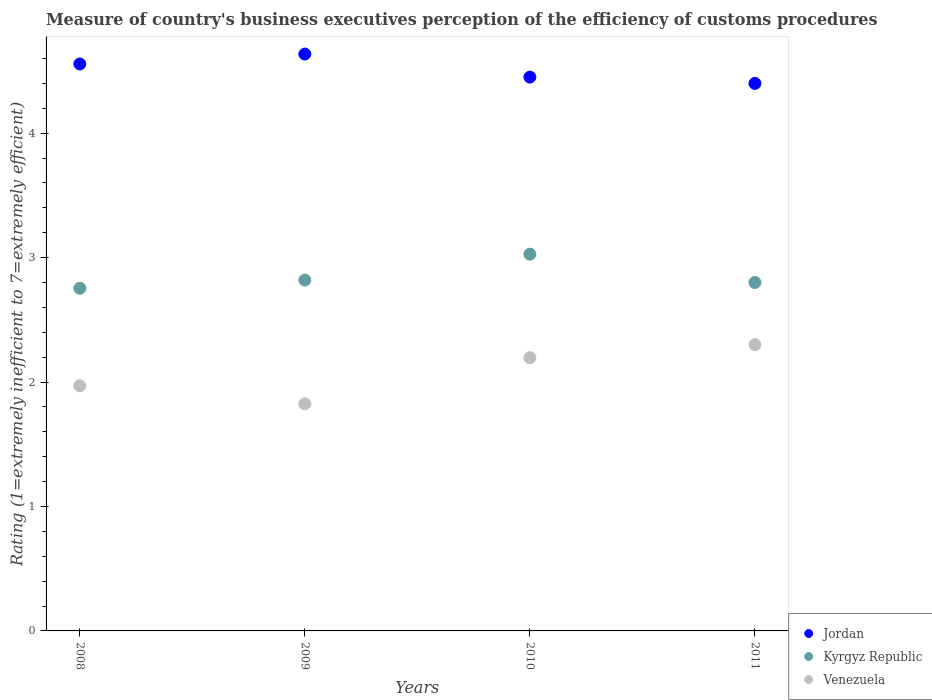What is the rating of the efficiency of customs procedure in Jordan in 2010?
Keep it short and to the point. 4.45. Across all years, what is the minimum rating of the efficiency of customs procedure in Venezuela?
Make the answer very short. 1.83. In which year was the rating of the efficiency of customs procedure in Kyrgyz Republic minimum?
Give a very brief answer. 2008. What is the total rating of the efficiency of customs procedure in Kyrgyz Republic in the graph?
Your response must be concise. 11.4. What is the difference between the rating of the efficiency of customs procedure in Jordan in 2010 and that in 2011?
Offer a terse response. 0.05. What is the difference between the rating of the efficiency of customs procedure in Jordan in 2011 and the rating of the efficiency of customs procedure in Kyrgyz Republic in 2008?
Your answer should be compact. 1.65. What is the average rating of the efficiency of customs procedure in Jordan per year?
Provide a short and direct response. 4.51. In the year 2009, what is the difference between the rating of the efficiency of customs procedure in Venezuela and rating of the efficiency of customs procedure in Jordan?
Keep it short and to the point. -2.81. In how many years, is the rating of the efficiency of customs procedure in Kyrgyz Republic greater than 4.4?
Keep it short and to the point. 0. What is the ratio of the rating of the efficiency of customs procedure in Kyrgyz Republic in 2008 to that in 2011?
Offer a very short reply. 0.98. Is the rating of the efficiency of customs procedure in Venezuela in 2008 less than that in 2009?
Ensure brevity in your answer.  No. What is the difference between the highest and the second highest rating of the efficiency of customs procedure in Venezuela?
Give a very brief answer. 0.1. What is the difference between the highest and the lowest rating of the efficiency of customs procedure in Kyrgyz Republic?
Provide a succinct answer. 0.27. Is the sum of the rating of the efficiency of customs procedure in Kyrgyz Republic in 2008 and 2009 greater than the maximum rating of the efficiency of customs procedure in Venezuela across all years?
Offer a very short reply. Yes. Is the rating of the efficiency of customs procedure in Venezuela strictly greater than the rating of the efficiency of customs procedure in Kyrgyz Republic over the years?
Give a very brief answer. No. How many dotlines are there?
Offer a terse response. 3. What is the difference between two consecutive major ticks on the Y-axis?
Ensure brevity in your answer.  1. Where does the legend appear in the graph?
Give a very brief answer. Bottom right. How many legend labels are there?
Ensure brevity in your answer.  3. How are the legend labels stacked?
Your answer should be compact. Vertical. What is the title of the graph?
Your answer should be very brief. Measure of country's business executives perception of the efficiency of customs procedures. What is the label or title of the Y-axis?
Offer a very short reply. Rating (1=extremely inefficient to 7=extremely efficient). What is the Rating (1=extremely inefficient to 7=extremely efficient) in Jordan in 2008?
Give a very brief answer. 4.56. What is the Rating (1=extremely inefficient to 7=extremely efficient) of Kyrgyz Republic in 2008?
Provide a short and direct response. 2.75. What is the Rating (1=extremely inefficient to 7=extremely efficient) of Venezuela in 2008?
Provide a short and direct response. 1.97. What is the Rating (1=extremely inefficient to 7=extremely efficient) of Jordan in 2009?
Your response must be concise. 4.64. What is the Rating (1=extremely inefficient to 7=extremely efficient) of Kyrgyz Republic in 2009?
Ensure brevity in your answer.  2.82. What is the Rating (1=extremely inefficient to 7=extremely efficient) of Venezuela in 2009?
Give a very brief answer. 1.83. What is the Rating (1=extremely inefficient to 7=extremely efficient) of Jordan in 2010?
Offer a terse response. 4.45. What is the Rating (1=extremely inefficient to 7=extremely efficient) in Kyrgyz Republic in 2010?
Provide a short and direct response. 3.03. What is the Rating (1=extremely inefficient to 7=extremely efficient) of Venezuela in 2010?
Offer a very short reply. 2.2. What is the Rating (1=extremely inefficient to 7=extremely efficient) of Venezuela in 2011?
Offer a very short reply. 2.3. Across all years, what is the maximum Rating (1=extremely inefficient to 7=extremely efficient) in Jordan?
Provide a short and direct response. 4.64. Across all years, what is the maximum Rating (1=extremely inefficient to 7=extremely efficient) in Kyrgyz Republic?
Offer a very short reply. 3.03. Across all years, what is the minimum Rating (1=extremely inefficient to 7=extremely efficient) in Kyrgyz Republic?
Offer a terse response. 2.75. Across all years, what is the minimum Rating (1=extremely inefficient to 7=extremely efficient) in Venezuela?
Give a very brief answer. 1.83. What is the total Rating (1=extremely inefficient to 7=extremely efficient) of Jordan in the graph?
Offer a terse response. 18.04. What is the total Rating (1=extremely inefficient to 7=extremely efficient) of Kyrgyz Republic in the graph?
Your response must be concise. 11.4. What is the total Rating (1=extremely inefficient to 7=extremely efficient) of Venezuela in the graph?
Provide a short and direct response. 8.29. What is the difference between the Rating (1=extremely inefficient to 7=extremely efficient) in Jordan in 2008 and that in 2009?
Your response must be concise. -0.08. What is the difference between the Rating (1=extremely inefficient to 7=extremely efficient) of Kyrgyz Republic in 2008 and that in 2009?
Provide a short and direct response. -0.07. What is the difference between the Rating (1=extremely inefficient to 7=extremely efficient) of Venezuela in 2008 and that in 2009?
Ensure brevity in your answer.  0.14. What is the difference between the Rating (1=extremely inefficient to 7=extremely efficient) of Jordan in 2008 and that in 2010?
Offer a terse response. 0.11. What is the difference between the Rating (1=extremely inefficient to 7=extremely efficient) of Kyrgyz Republic in 2008 and that in 2010?
Ensure brevity in your answer.  -0.27. What is the difference between the Rating (1=extremely inefficient to 7=extremely efficient) in Venezuela in 2008 and that in 2010?
Give a very brief answer. -0.23. What is the difference between the Rating (1=extremely inefficient to 7=extremely efficient) in Jordan in 2008 and that in 2011?
Provide a succinct answer. 0.16. What is the difference between the Rating (1=extremely inefficient to 7=extremely efficient) of Kyrgyz Republic in 2008 and that in 2011?
Provide a short and direct response. -0.05. What is the difference between the Rating (1=extremely inefficient to 7=extremely efficient) of Venezuela in 2008 and that in 2011?
Make the answer very short. -0.33. What is the difference between the Rating (1=extremely inefficient to 7=extremely efficient) of Jordan in 2009 and that in 2010?
Your response must be concise. 0.19. What is the difference between the Rating (1=extremely inefficient to 7=extremely efficient) of Kyrgyz Republic in 2009 and that in 2010?
Your answer should be very brief. -0.21. What is the difference between the Rating (1=extremely inefficient to 7=extremely efficient) in Venezuela in 2009 and that in 2010?
Keep it short and to the point. -0.37. What is the difference between the Rating (1=extremely inefficient to 7=extremely efficient) in Jordan in 2009 and that in 2011?
Keep it short and to the point. 0.24. What is the difference between the Rating (1=extremely inefficient to 7=extremely efficient) of Kyrgyz Republic in 2009 and that in 2011?
Keep it short and to the point. 0.02. What is the difference between the Rating (1=extremely inefficient to 7=extremely efficient) in Venezuela in 2009 and that in 2011?
Offer a terse response. -0.47. What is the difference between the Rating (1=extremely inefficient to 7=extremely efficient) of Jordan in 2010 and that in 2011?
Offer a very short reply. 0.05. What is the difference between the Rating (1=extremely inefficient to 7=extremely efficient) of Kyrgyz Republic in 2010 and that in 2011?
Make the answer very short. 0.23. What is the difference between the Rating (1=extremely inefficient to 7=extremely efficient) of Venezuela in 2010 and that in 2011?
Your answer should be very brief. -0.1. What is the difference between the Rating (1=extremely inefficient to 7=extremely efficient) in Jordan in 2008 and the Rating (1=extremely inefficient to 7=extremely efficient) in Kyrgyz Republic in 2009?
Give a very brief answer. 1.74. What is the difference between the Rating (1=extremely inefficient to 7=extremely efficient) in Jordan in 2008 and the Rating (1=extremely inefficient to 7=extremely efficient) in Venezuela in 2009?
Ensure brevity in your answer.  2.73. What is the difference between the Rating (1=extremely inefficient to 7=extremely efficient) of Kyrgyz Republic in 2008 and the Rating (1=extremely inefficient to 7=extremely efficient) of Venezuela in 2009?
Offer a terse response. 0.93. What is the difference between the Rating (1=extremely inefficient to 7=extremely efficient) in Jordan in 2008 and the Rating (1=extremely inefficient to 7=extremely efficient) in Kyrgyz Republic in 2010?
Offer a terse response. 1.53. What is the difference between the Rating (1=extremely inefficient to 7=extremely efficient) of Jordan in 2008 and the Rating (1=extremely inefficient to 7=extremely efficient) of Venezuela in 2010?
Your response must be concise. 2.36. What is the difference between the Rating (1=extremely inefficient to 7=extremely efficient) in Kyrgyz Republic in 2008 and the Rating (1=extremely inefficient to 7=extremely efficient) in Venezuela in 2010?
Offer a very short reply. 0.56. What is the difference between the Rating (1=extremely inefficient to 7=extremely efficient) in Jordan in 2008 and the Rating (1=extremely inefficient to 7=extremely efficient) in Kyrgyz Republic in 2011?
Your answer should be compact. 1.76. What is the difference between the Rating (1=extremely inefficient to 7=extremely efficient) in Jordan in 2008 and the Rating (1=extremely inefficient to 7=extremely efficient) in Venezuela in 2011?
Provide a short and direct response. 2.26. What is the difference between the Rating (1=extremely inefficient to 7=extremely efficient) of Kyrgyz Republic in 2008 and the Rating (1=extremely inefficient to 7=extremely efficient) of Venezuela in 2011?
Offer a very short reply. 0.45. What is the difference between the Rating (1=extremely inefficient to 7=extremely efficient) of Jordan in 2009 and the Rating (1=extremely inefficient to 7=extremely efficient) of Kyrgyz Republic in 2010?
Make the answer very short. 1.61. What is the difference between the Rating (1=extremely inefficient to 7=extremely efficient) in Jordan in 2009 and the Rating (1=extremely inefficient to 7=extremely efficient) in Venezuela in 2010?
Give a very brief answer. 2.44. What is the difference between the Rating (1=extremely inefficient to 7=extremely efficient) in Kyrgyz Republic in 2009 and the Rating (1=extremely inefficient to 7=extremely efficient) in Venezuela in 2010?
Your answer should be very brief. 0.62. What is the difference between the Rating (1=extremely inefficient to 7=extremely efficient) in Jordan in 2009 and the Rating (1=extremely inefficient to 7=extremely efficient) in Kyrgyz Republic in 2011?
Keep it short and to the point. 1.84. What is the difference between the Rating (1=extremely inefficient to 7=extremely efficient) in Jordan in 2009 and the Rating (1=extremely inefficient to 7=extremely efficient) in Venezuela in 2011?
Ensure brevity in your answer.  2.34. What is the difference between the Rating (1=extremely inefficient to 7=extremely efficient) in Kyrgyz Republic in 2009 and the Rating (1=extremely inefficient to 7=extremely efficient) in Venezuela in 2011?
Offer a terse response. 0.52. What is the difference between the Rating (1=extremely inefficient to 7=extremely efficient) of Jordan in 2010 and the Rating (1=extremely inefficient to 7=extremely efficient) of Kyrgyz Republic in 2011?
Give a very brief answer. 1.65. What is the difference between the Rating (1=extremely inefficient to 7=extremely efficient) of Jordan in 2010 and the Rating (1=extremely inefficient to 7=extremely efficient) of Venezuela in 2011?
Provide a succinct answer. 2.15. What is the difference between the Rating (1=extremely inefficient to 7=extremely efficient) of Kyrgyz Republic in 2010 and the Rating (1=extremely inefficient to 7=extremely efficient) of Venezuela in 2011?
Your answer should be very brief. 0.73. What is the average Rating (1=extremely inefficient to 7=extremely efficient) of Jordan per year?
Your answer should be very brief. 4.51. What is the average Rating (1=extremely inefficient to 7=extremely efficient) of Kyrgyz Republic per year?
Your response must be concise. 2.85. What is the average Rating (1=extremely inefficient to 7=extremely efficient) of Venezuela per year?
Ensure brevity in your answer.  2.07. In the year 2008, what is the difference between the Rating (1=extremely inefficient to 7=extremely efficient) of Jordan and Rating (1=extremely inefficient to 7=extremely efficient) of Kyrgyz Republic?
Your answer should be compact. 1.8. In the year 2008, what is the difference between the Rating (1=extremely inefficient to 7=extremely efficient) in Jordan and Rating (1=extremely inefficient to 7=extremely efficient) in Venezuela?
Your answer should be compact. 2.59. In the year 2008, what is the difference between the Rating (1=extremely inefficient to 7=extremely efficient) of Kyrgyz Republic and Rating (1=extremely inefficient to 7=extremely efficient) of Venezuela?
Your response must be concise. 0.78. In the year 2009, what is the difference between the Rating (1=extremely inefficient to 7=extremely efficient) in Jordan and Rating (1=extremely inefficient to 7=extremely efficient) in Kyrgyz Republic?
Ensure brevity in your answer.  1.82. In the year 2009, what is the difference between the Rating (1=extremely inefficient to 7=extremely efficient) of Jordan and Rating (1=extremely inefficient to 7=extremely efficient) of Venezuela?
Your response must be concise. 2.81. In the year 2010, what is the difference between the Rating (1=extremely inefficient to 7=extremely efficient) in Jordan and Rating (1=extremely inefficient to 7=extremely efficient) in Kyrgyz Republic?
Offer a very short reply. 1.42. In the year 2010, what is the difference between the Rating (1=extremely inefficient to 7=extremely efficient) in Jordan and Rating (1=extremely inefficient to 7=extremely efficient) in Venezuela?
Offer a very short reply. 2.26. In the year 2010, what is the difference between the Rating (1=extremely inefficient to 7=extremely efficient) of Kyrgyz Republic and Rating (1=extremely inefficient to 7=extremely efficient) of Venezuela?
Keep it short and to the point. 0.83. In the year 2011, what is the difference between the Rating (1=extremely inefficient to 7=extremely efficient) of Kyrgyz Republic and Rating (1=extremely inefficient to 7=extremely efficient) of Venezuela?
Your answer should be compact. 0.5. What is the ratio of the Rating (1=extremely inefficient to 7=extremely efficient) of Jordan in 2008 to that in 2009?
Provide a succinct answer. 0.98. What is the ratio of the Rating (1=extremely inefficient to 7=extremely efficient) in Kyrgyz Republic in 2008 to that in 2009?
Provide a succinct answer. 0.98. What is the ratio of the Rating (1=extremely inefficient to 7=extremely efficient) of Venezuela in 2008 to that in 2009?
Provide a short and direct response. 1.08. What is the ratio of the Rating (1=extremely inefficient to 7=extremely efficient) of Jordan in 2008 to that in 2010?
Keep it short and to the point. 1.02. What is the ratio of the Rating (1=extremely inefficient to 7=extremely efficient) in Kyrgyz Republic in 2008 to that in 2010?
Your response must be concise. 0.91. What is the ratio of the Rating (1=extremely inefficient to 7=extremely efficient) of Venezuela in 2008 to that in 2010?
Give a very brief answer. 0.9. What is the ratio of the Rating (1=extremely inefficient to 7=extremely efficient) in Jordan in 2008 to that in 2011?
Your response must be concise. 1.04. What is the ratio of the Rating (1=extremely inefficient to 7=extremely efficient) in Kyrgyz Republic in 2008 to that in 2011?
Provide a succinct answer. 0.98. What is the ratio of the Rating (1=extremely inefficient to 7=extremely efficient) of Venezuela in 2008 to that in 2011?
Your response must be concise. 0.86. What is the ratio of the Rating (1=extremely inefficient to 7=extremely efficient) of Jordan in 2009 to that in 2010?
Provide a succinct answer. 1.04. What is the ratio of the Rating (1=extremely inefficient to 7=extremely efficient) in Kyrgyz Republic in 2009 to that in 2010?
Ensure brevity in your answer.  0.93. What is the ratio of the Rating (1=extremely inefficient to 7=extremely efficient) of Venezuela in 2009 to that in 2010?
Your answer should be compact. 0.83. What is the ratio of the Rating (1=extremely inefficient to 7=extremely efficient) of Jordan in 2009 to that in 2011?
Offer a very short reply. 1.05. What is the ratio of the Rating (1=extremely inefficient to 7=extremely efficient) in Kyrgyz Republic in 2009 to that in 2011?
Offer a terse response. 1.01. What is the ratio of the Rating (1=extremely inefficient to 7=extremely efficient) in Venezuela in 2009 to that in 2011?
Your answer should be very brief. 0.79. What is the ratio of the Rating (1=extremely inefficient to 7=extremely efficient) in Jordan in 2010 to that in 2011?
Your response must be concise. 1.01. What is the ratio of the Rating (1=extremely inefficient to 7=extremely efficient) of Kyrgyz Republic in 2010 to that in 2011?
Give a very brief answer. 1.08. What is the ratio of the Rating (1=extremely inefficient to 7=extremely efficient) of Venezuela in 2010 to that in 2011?
Offer a terse response. 0.95. What is the difference between the highest and the second highest Rating (1=extremely inefficient to 7=extremely efficient) in Jordan?
Provide a short and direct response. 0.08. What is the difference between the highest and the second highest Rating (1=extremely inefficient to 7=extremely efficient) of Kyrgyz Republic?
Provide a short and direct response. 0.21. What is the difference between the highest and the second highest Rating (1=extremely inefficient to 7=extremely efficient) of Venezuela?
Ensure brevity in your answer.  0.1. What is the difference between the highest and the lowest Rating (1=extremely inefficient to 7=extremely efficient) of Jordan?
Your answer should be compact. 0.24. What is the difference between the highest and the lowest Rating (1=extremely inefficient to 7=extremely efficient) in Kyrgyz Republic?
Your answer should be very brief. 0.27. What is the difference between the highest and the lowest Rating (1=extremely inefficient to 7=extremely efficient) of Venezuela?
Keep it short and to the point. 0.47. 